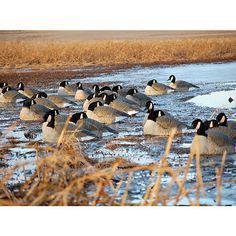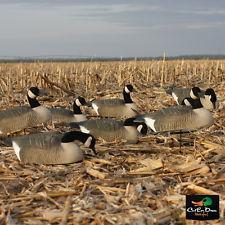The first image is the image on the left, the second image is the image on the right. Considering the images on both sides, is "Ducks in the left image are in water." valid? Answer yes or no. Yes. The first image is the image on the left, the second image is the image on the right. Given the left and right images, does the statement "Both images show a flock of canada geese, but in only one of the images are the geese in water." hold true? Answer yes or no. Yes. 